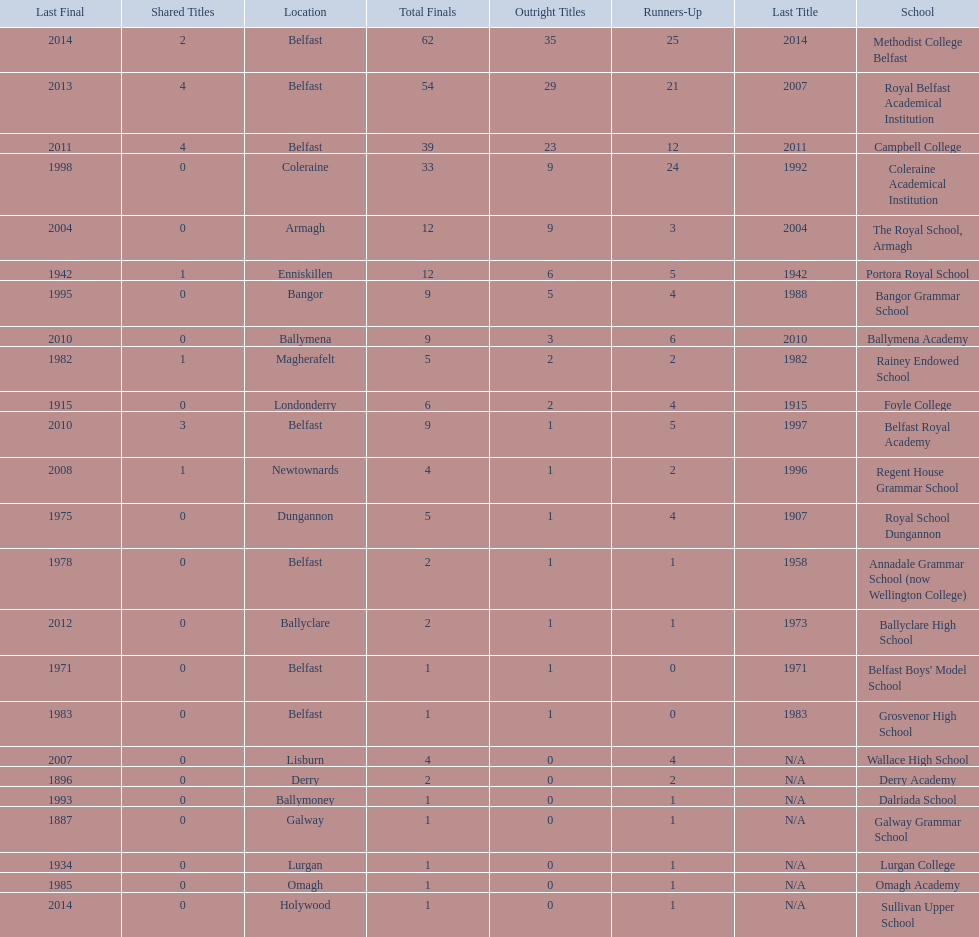How many schools are there? Methodist College Belfast, Royal Belfast Academical Institution, Campbell College, Coleraine Academical Institution, The Royal School, Armagh, Portora Royal School, Bangor Grammar School, Ballymena Academy, Rainey Endowed School, Foyle College, Belfast Royal Academy, Regent House Grammar School, Royal School Dungannon, Annadale Grammar School (now Wellington College), Ballyclare High School, Belfast Boys' Model School, Grosvenor High School, Wallace High School, Derry Academy, Dalriada School, Galway Grammar School, Lurgan College, Omagh Academy, Sullivan Upper School. How many outright titles does the coleraine academical institution have? 9. What other school has the same number of outright titles? The Royal School, Armagh. 